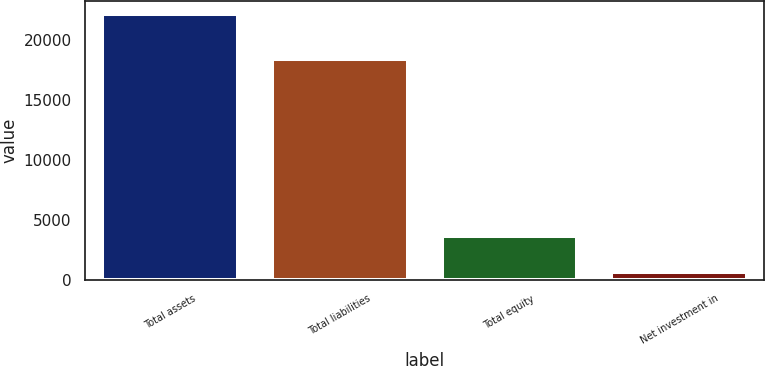<chart> <loc_0><loc_0><loc_500><loc_500><bar_chart><fcel>Total assets<fcel>Total liabilities<fcel>Total equity<fcel>Net investment in<nl><fcel>22086<fcel>18362.3<fcel>3723.7<fcel>669.4<nl></chart> 